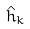<formula> <loc_0><loc_0><loc_500><loc_500>\hat { h } _ { k }</formula> 